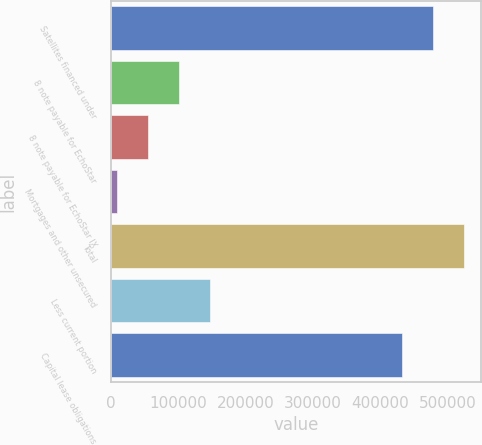Convert chart. <chart><loc_0><loc_0><loc_500><loc_500><bar_chart><fcel>Satellites financed under<fcel>8 note payable for EchoStar<fcel>8 note payable for EchoStar IX<fcel>Mortgages and other unsecured<fcel>Total<fcel>Less current portion<fcel>Capital lease obligations<nl><fcel>477861<fcel>100387<fcel>54392.8<fcel>8399<fcel>523855<fcel>146380<fcel>431867<nl></chart> 